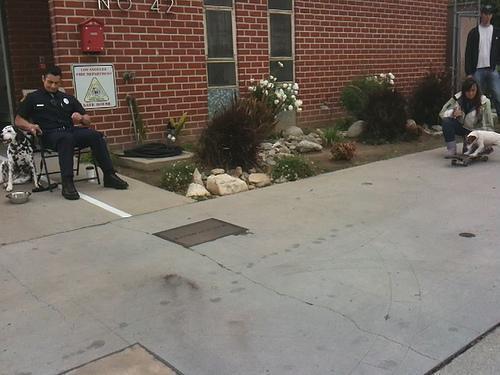Who is the man sitting by the building entrance?
Indicate the correct response by choosing from the four available options to answer the question.
Options: Security guard, driver, receptionist, greeter. Security guard. 